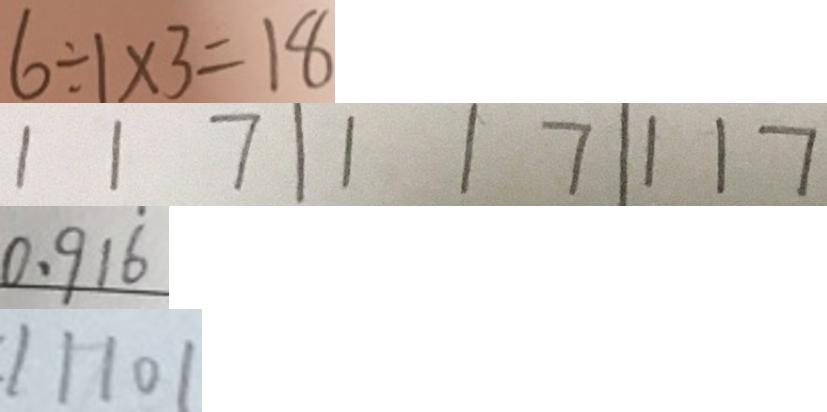<formula> <loc_0><loc_0><loc_500><loc_500>6 \div 1 \times 3 = 1 8 
 1 1 7 \vert 1 1 7 \vert 1 1 7 
 0 . 9 1 \dot { 6 } 
 1 1 1 0 1</formula> 